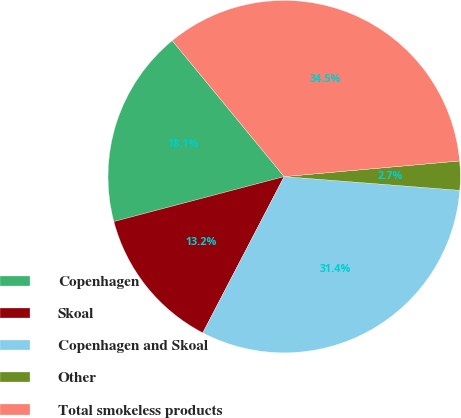<chart> <loc_0><loc_0><loc_500><loc_500><pie_chart><fcel>Copenhagen<fcel>Skoal<fcel>Copenhagen and Skoal<fcel>Other<fcel>Total smokeless products<nl><fcel>18.15%<fcel>13.25%<fcel>31.4%<fcel>2.66%<fcel>34.54%<nl></chart> 